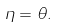Convert formula to latex. <formula><loc_0><loc_0><loc_500><loc_500>\eta = \theta .</formula> 